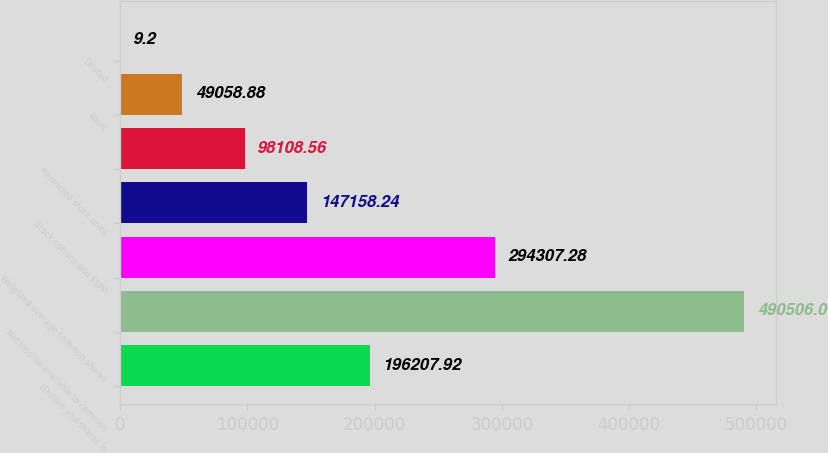Convert chart. <chart><loc_0><loc_0><loc_500><loc_500><bar_chart><fcel>(Dollars and shares in<fcel>Net income available to common<fcel>Weighted average common shares<fcel>Stock options and ESPP<fcel>Restricted stock units<fcel>Basic<fcel>Diluted<nl><fcel>196208<fcel>490506<fcel>294307<fcel>147158<fcel>98108.6<fcel>49058.9<fcel>9.2<nl></chart> 